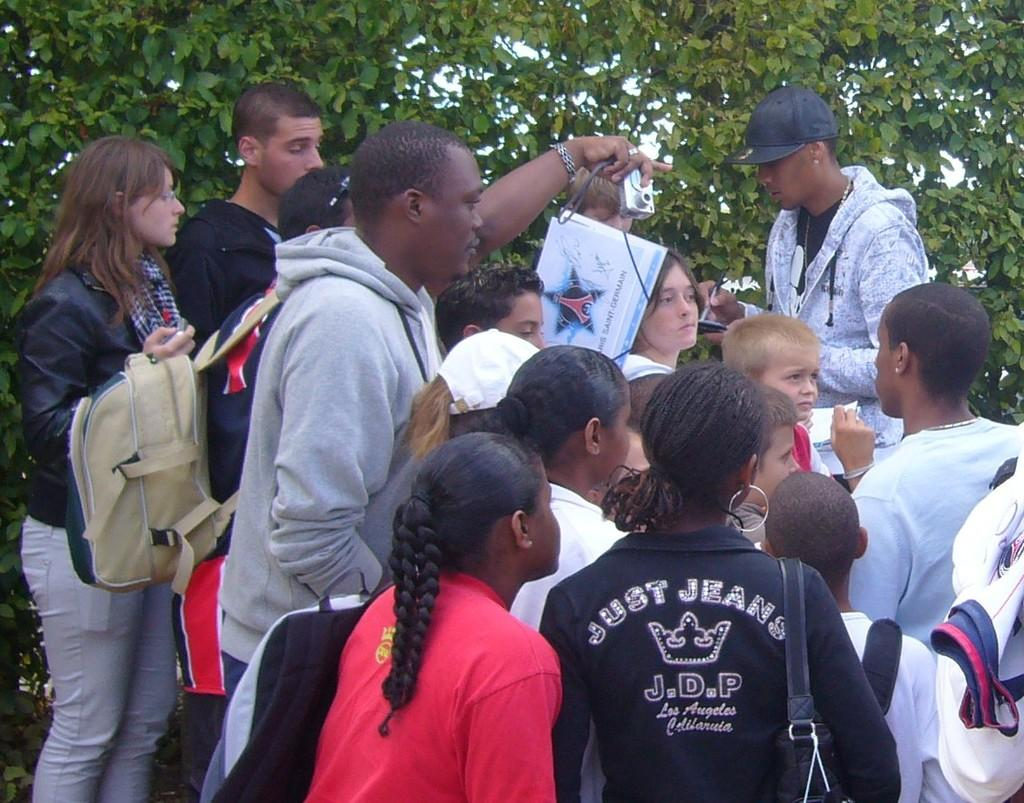How many people are in the image? There is a group of persons in the image. What are the persons holding in the image? The persons are holding bags, papers, and a camera. What can be seen in the background of the image? There are trees visible at the top of the image. How does the car start in the image? There is no car present in the image. Can you describe the jump the persons are performing in the image? The persons are not jumping in the image; they are holding various items. 